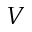Convert formula to latex. <formula><loc_0><loc_0><loc_500><loc_500>V</formula> 